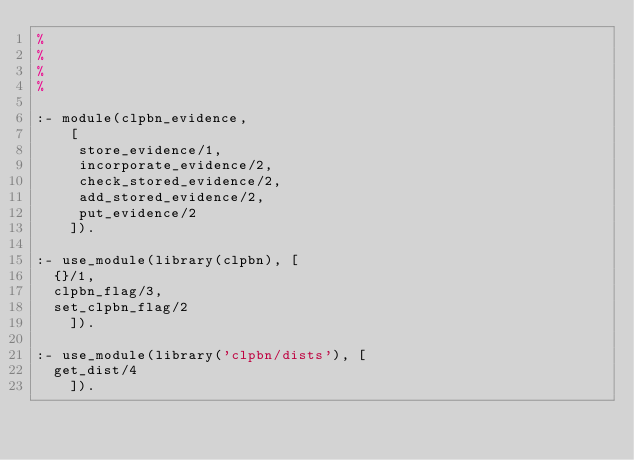<code> <loc_0><loc_0><loc_500><loc_500><_Prolog_>%
%
%
%

:- module(clpbn_evidence,
	  [
	   store_evidence/1,
	   incorporate_evidence/2,
	   check_stored_evidence/2,
	   add_stored_evidence/2,
	   put_evidence/2
	  ]).

:- use_module(library(clpbn), [
	{}/1,
	clpbn_flag/3,
	set_clpbn_flag/2
    ]).

:- use_module(library('clpbn/dists'), [
	get_dist/4
    ]).
</code> 